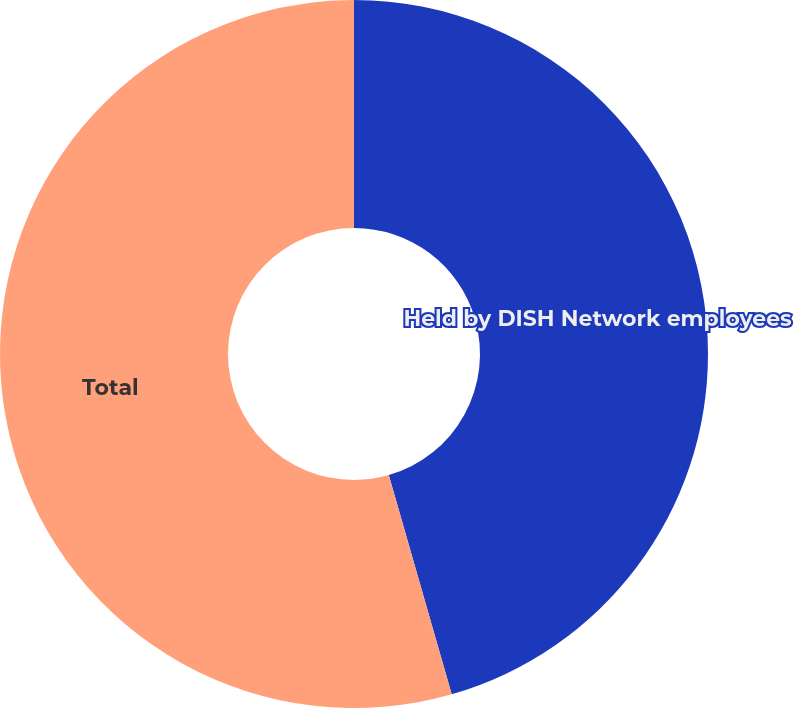<chart> <loc_0><loc_0><loc_500><loc_500><pie_chart><fcel>Held by DISH Network employees<fcel>Total<nl><fcel>45.55%<fcel>54.45%<nl></chart> 